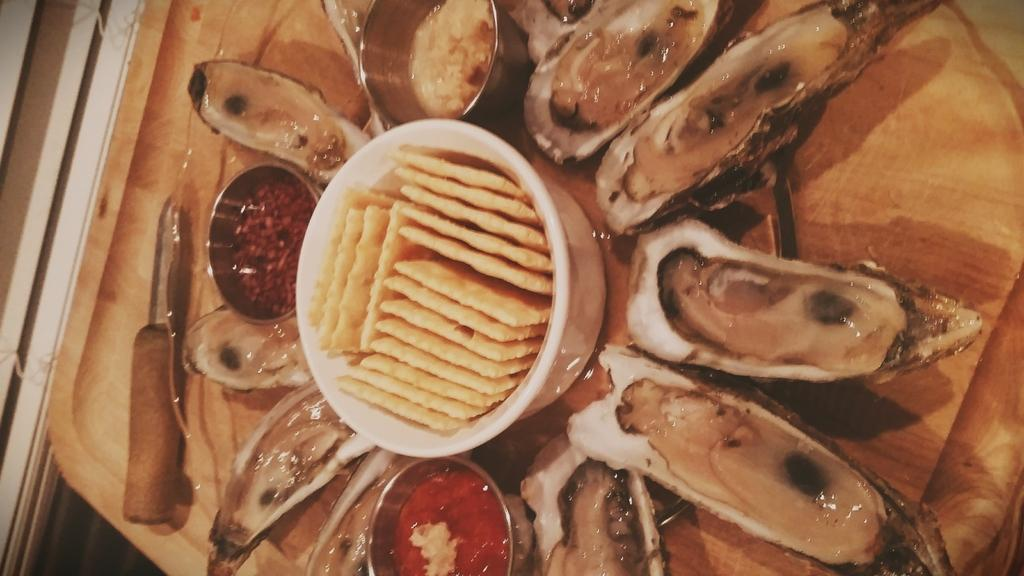What type of food can be seen in the image? There is cooked food in the image. What is the food served on? The food is served on a wooden plate. Are there any condiments or additional flavors present in the image? Yes, there are different sauces present in the image. How are the sauces arranged in relation to the food? The sauces are placed between the food items. What type of shock can be seen in the image? There is no shock present in the image; it features cooked food served on a wooden plate with different sauces. What type of potato is used in the dish in the image? There is no potato present in the image; it features cooked food served on a wooden plate with different sauces. 